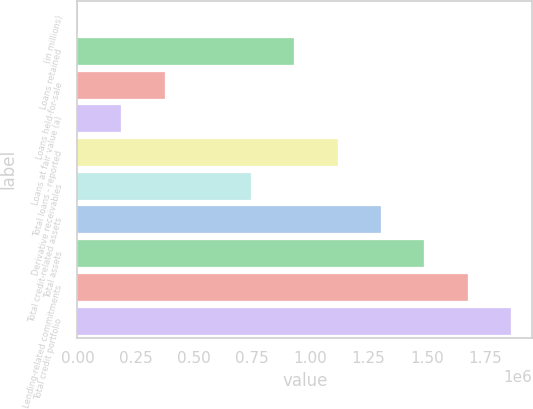Convert chart to OTSL. <chart><loc_0><loc_0><loc_500><loc_500><bar_chart><fcel>(in millions)<fcel>Loans retained<fcel>Loans held-for-sale<fcel>Loans at fair value (a)<fcel>Total loans - reported<fcel>Derivative receivables<fcel>Total credit-related assets<fcel>Total assets<fcel>Lending-related commitments<fcel>Total credit portfolio<nl><fcel>2012<fcel>931270<fcel>373715<fcel>187864<fcel>1.11712e+06<fcel>745418<fcel>1.30297e+06<fcel>1.48882e+06<fcel>1.67468e+06<fcel>1.86053e+06<nl></chart> 